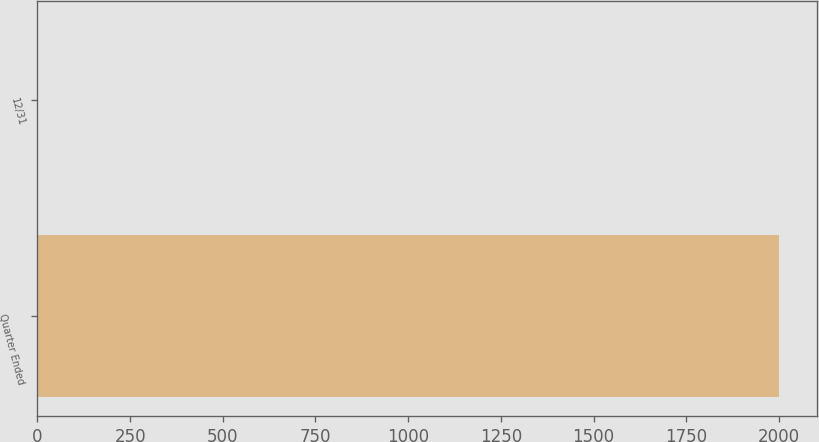Convert chart. <chart><loc_0><loc_0><loc_500><loc_500><bar_chart><fcel>Quarter Ended<fcel>12/31<nl><fcel>2001<fcel>0.7<nl></chart> 